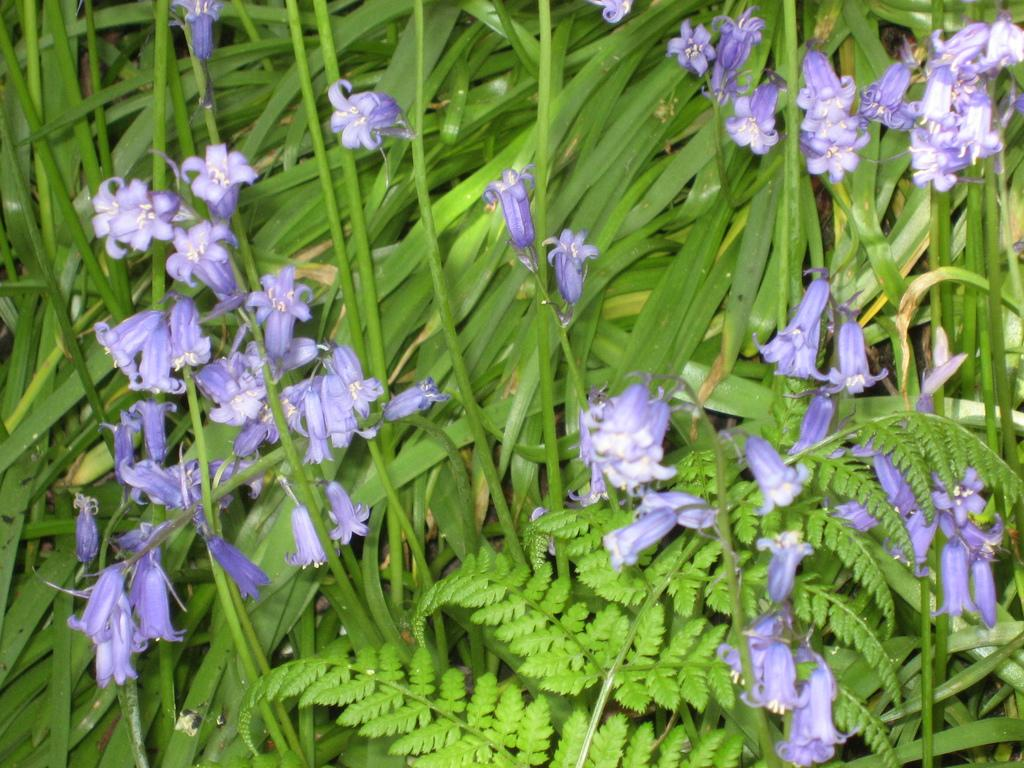What color are the flowers in the image? The flowers in the image are purple. What are the flowers growing on? The flowers are on plants. How many different types of plants can be seen in the image? There are two different types of plants in the image. Can you see the vein of the father in the image? There is no father or vein present in the image; it features purple flowers on plants. 